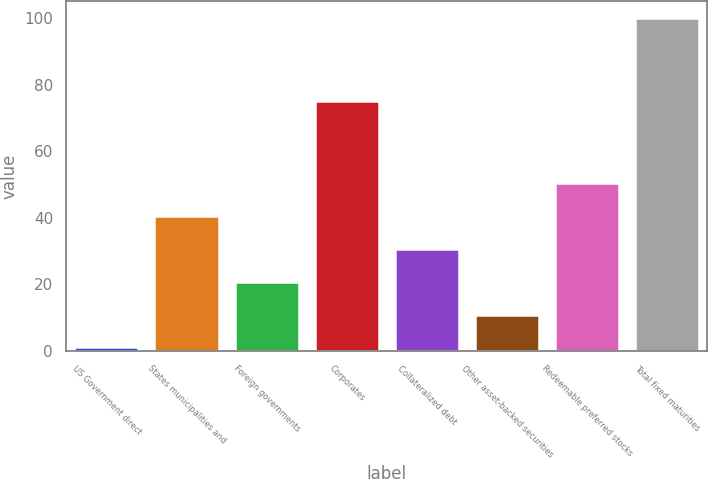Convert chart. <chart><loc_0><loc_0><loc_500><loc_500><bar_chart><fcel>US Government direct<fcel>States municipalities and<fcel>Foreign governments<fcel>Corporates<fcel>Collateralized debt<fcel>Other asset-backed securities<fcel>Redeemable preferred stocks<fcel>Total fixed maturities<nl><fcel>1<fcel>40.6<fcel>20.8<fcel>75<fcel>30.7<fcel>10.9<fcel>50.5<fcel>100<nl></chart> 